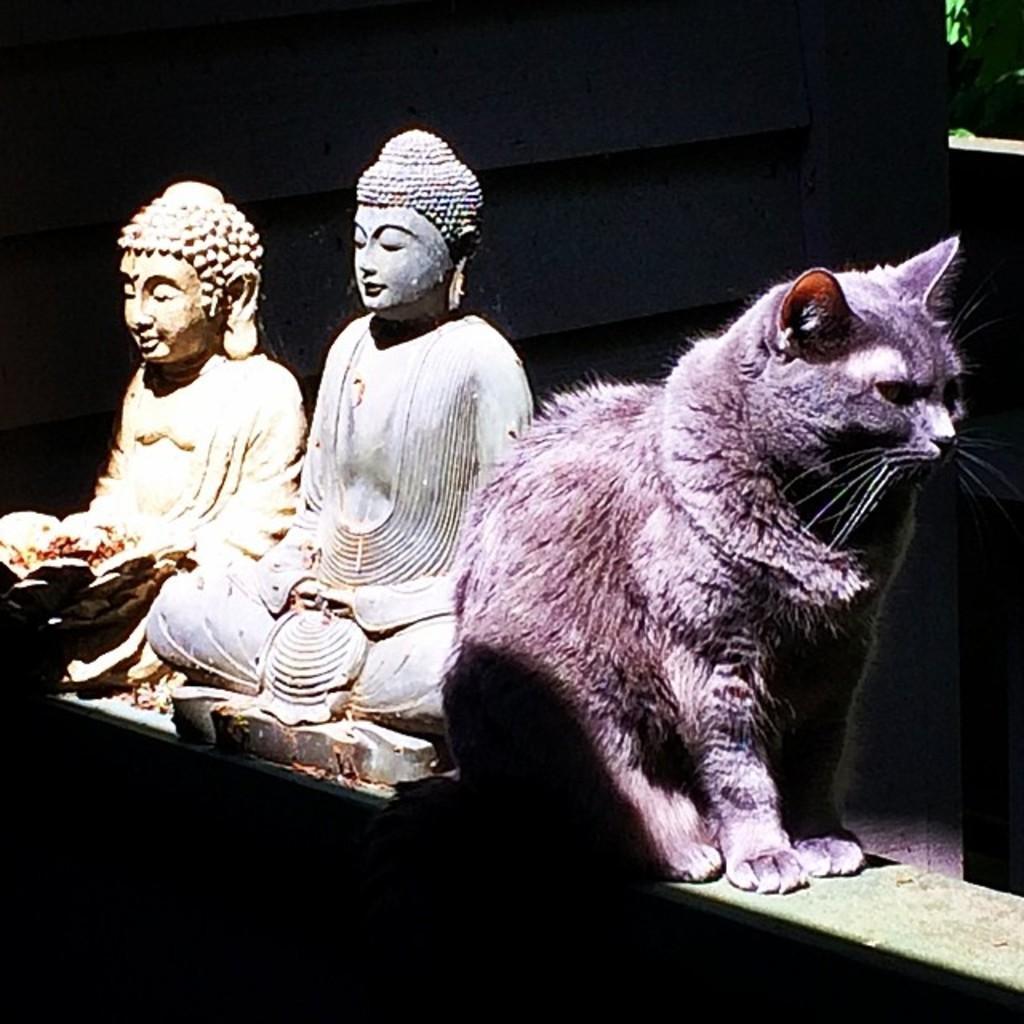Could you give a brief overview of what you see in this image? In this image there is a cat sitting beside the buddha sculptures. 